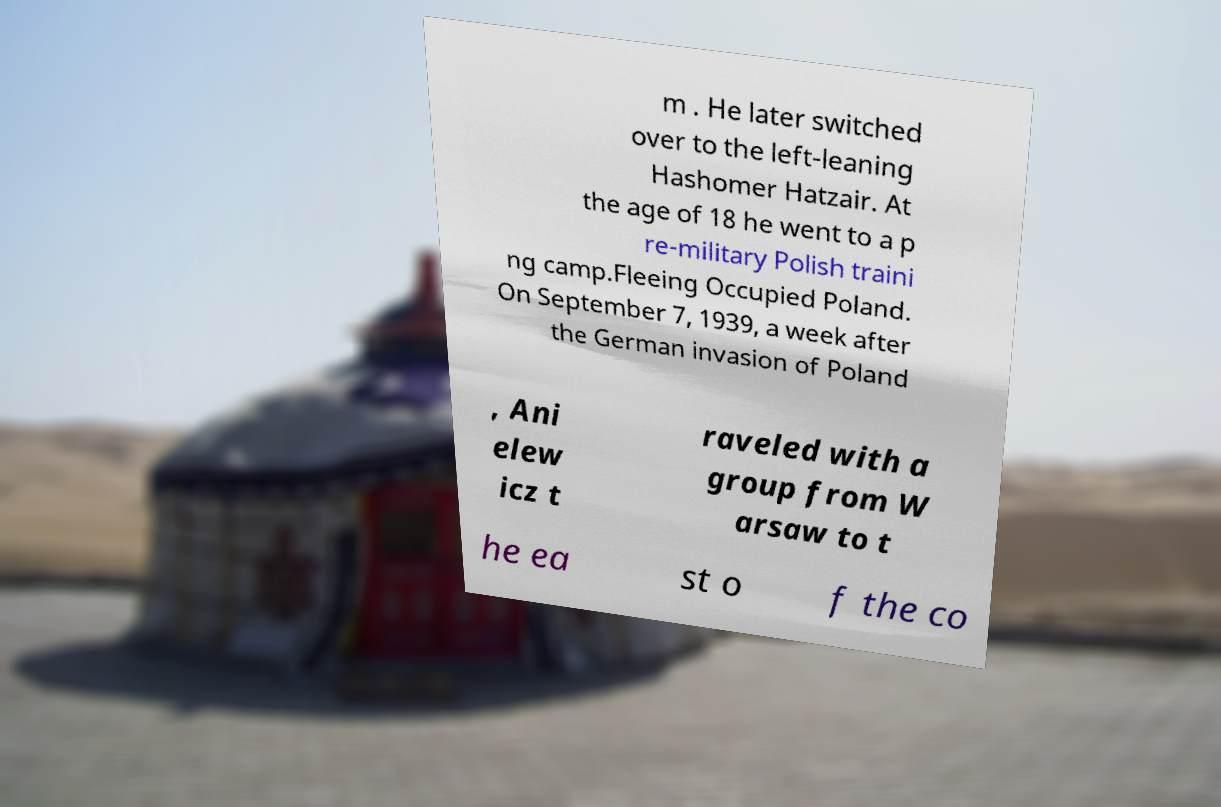What messages or text are displayed in this image? I need them in a readable, typed format. m . He later switched over to the left-leaning Hashomer Hatzair. At the age of 18 he went to a p re-military Polish traini ng camp.Fleeing Occupied Poland. On September 7, 1939, a week after the German invasion of Poland , Ani elew icz t raveled with a group from W arsaw to t he ea st o f the co 